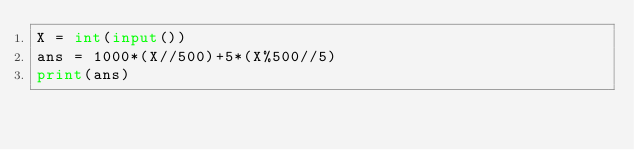Convert code to text. <code><loc_0><loc_0><loc_500><loc_500><_Python_>X = int(input())
ans = 1000*(X//500)+5*(X%500//5)
print(ans)
</code> 